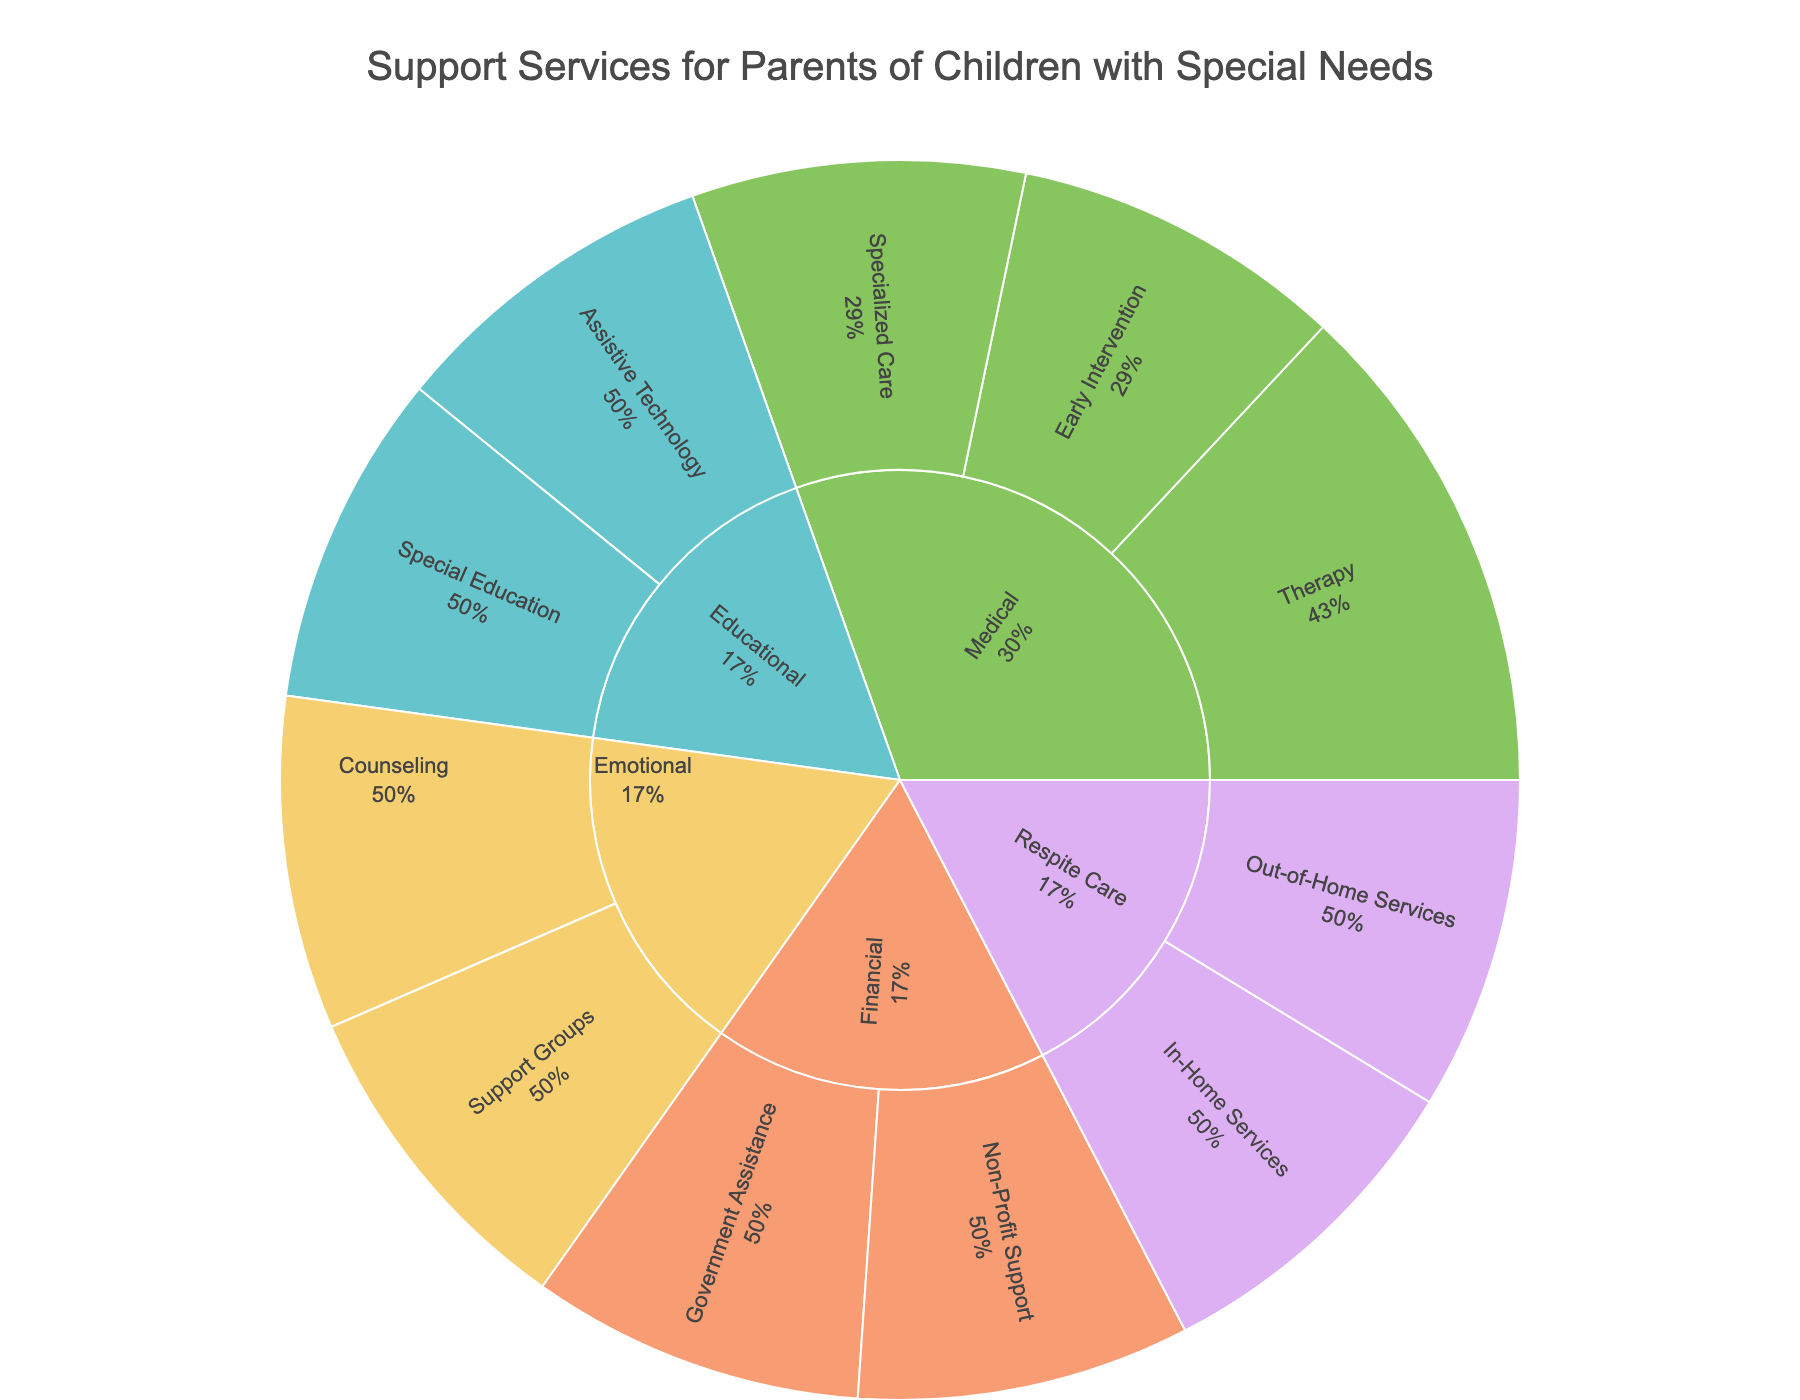what is the main title of the sunburst plot? The main title is usually displayed prominently at the top of the plot. From the code, it is mentioned that the title fed into the plot is "Support Services for Parents of Children with Special Needs".
Answer: Support Services for Parents of Children with Special Needs Which category has the most sub-categories? By looking at the plot, you can see the initial segments of each color which represent the main categories, then count the sub-segments under them. From the data, the category Medical has three types (Early Intervention, Therapy, Specialized Care).
Answer: Medical Which services fall under Financial > Government Assistance? First, find the Financial category. Then, under the Government Assistance type, you should see the individual services listed. From the data given, these are Supplemental Security Income (SSI) and Medicaid Waivers.
Answer: Supplemental Security Income (SSI), Medicaid Waivers What percentage of the Medical category services are classified under Therapy? First, identify the three types of services under Medical category. Then count the individual services under each type. The Therapy category has 3 services (Physical Therapy, Occupational Therapy, Speech Therapy) out of a total of 8 services in the Medical category. This constitutes \( \frac{3}{8} \times 100 = 37.5\% \).
Answer: 37.5% Which category offers Respite Centers? To answer this question, look at the categories and find the one that includes the Respite Centers service. From our data, Respite Centers fall under the Respite Care category.
Answer: Respite Care How many types of services are there in the Emotional category? Identify the Emotional category in the sunburst plot. Count the number of distinct types under this category. The data shows there are 2 types (Support Groups, Counseling).
Answer: 2 Which has more services within it: Educational Assistive Technology or Financial Non-Profit Support? Compare the number of services under Educational Assistive Technology (which has 2 services: Communication Devices, Adaptive Learning Software) with Financial Non-Profit Support (which also has 2 services: Grants for Adaptive Equipment, Scholarships for Special Needs Education).
Answer: They have an equal number of services List all services available in Medical > Specialized Care. First, locate the Medical category, then navigate to the Specialized Care type within it. According to the data, the services listed under Specialized Care are Pediatric Neurology and Genetic Counseling.
Answer: Pediatric Neurology, Genetic Counseling What is the main difference between Respite Care in-home services and out-of-home services? Compare the services listed under In-Home Services with those listed under Out-of-Home Services within the Respite Care category. The In-Home Services include Skilled Nursing Care and Personal Care Assistance, whereas Out-of-Home Services include Respite Centers and Special Needs Camps.
Answer: In-home: Skilled Nursing Care, Personal Care Assistance; Out-of-home: Respite Centers, Special Needs Camps Among the Educational services, which are directly related to technology? Find the services within the Educational category and identify which ones are related to technology. The Assistive Technology type includes Communication Devices and Adaptive Learning Software.
Answer: Communication Devices, Adaptive Learning Software 